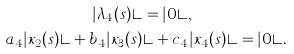Convert formula to latex. <formula><loc_0><loc_0><loc_500><loc_500>| \lambda _ { 4 } ( s ) \rangle & = | 0 \rangle , \\ a _ { 4 } | \kappa _ { 2 } ( s ) \rangle + b _ { 4 } | \kappa _ { 3 } ( s ) & \rangle + c _ { 4 } | \kappa _ { 4 } ( s ) \rangle = | 0 \rangle .</formula> 